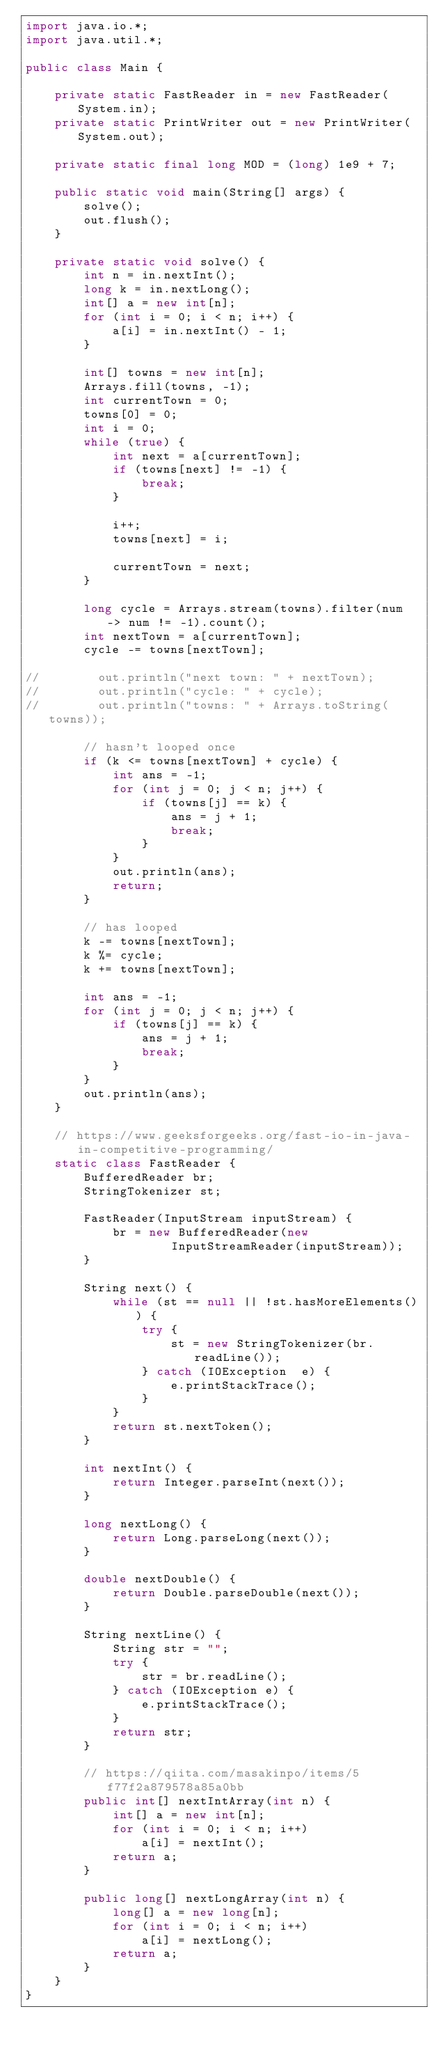Convert code to text. <code><loc_0><loc_0><loc_500><loc_500><_Java_>import java.io.*;
import java.util.*;

public class Main {

    private static FastReader in = new FastReader(System.in);
    private static PrintWriter out = new PrintWriter(System.out);

    private static final long MOD = (long) 1e9 + 7;

    public static void main(String[] args) {
        solve();
        out.flush();
    }

    private static void solve() {
        int n = in.nextInt();
        long k = in.nextLong();
        int[] a = new int[n];
        for (int i = 0; i < n; i++) {
            a[i] = in.nextInt() - 1;
        }

        int[] towns = new int[n];
        Arrays.fill(towns, -1);
        int currentTown = 0;
        towns[0] = 0;
        int i = 0;
        while (true) {
            int next = a[currentTown];
            if (towns[next] != -1) {
                break;
            }

            i++;
            towns[next] = i;

            currentTown = next;
        }

        long cycle = Arrays.stream(towns).filter(num -> num != -1).count();
        int nextTown = a[currentTown];
        cycle -= towns[nextTown];

//        out.println("next town: " + nextTown);
//        out.println("cycle: " + cycle);
//        out.println("towns: " + Arrays.toString(towns));

        // hasn't looped once
        if (k <= towns[nextTown] + cycle) {
            int ans = -1;
            for (int j = 0; j < n; j++) {
                if (towns[j] == k) {
                    ans = j + 1;
                    break;
                }
            }
            out.println(ans);
            return;
        }

        // has looped
        k -= towns[nextTown];
        k %= cycle;
        k += towns[nextTown];

        int ans = -1;
        for (int j = 0; j < n; j++) {
            if (towns[j] == k) {
                ans = j + 1;
                break;
            }
        }
        out.println(ans);
    }

    // https://www.geeksforgeeks.org/fast-io-in-java-in-competitive-programming/
    static class FastReader {
        BufferedReader br;
        StringTokenizer st;

        FastReader(InputStream inputStream) {
            br = new BufferedReader(new
                    InputStreamReader(inputStream));
        }

        String next() {
            while (st == null || !st.hasMoreElements()) {
                try {
                    st = new StringTokenizer(br.readLine());
                } catch (IOException  e) {
                    e.printStackTrace();
                }
            }
            return st.nextToken();
        }

        int nextInt() {
            return Integer.parseInt(next());
        }

        long nextLong() {
            return Long.parseLong(next());
        }

        double nextDouble() {
            return Double.parseDouble(next());
        }

        String nextLine() {
            String str = "";
            try {
                str = br.readLine();
            } catch (IOException e) {
                e.printStackTrace();
            }
            return str;
        }

        // https://qiita.com/masakinpo/items/5f77f2a879578a85a0bb
        public int[] nextIntArray(int n) {
            int[] a = new int[n];
            for (int i = 0; i < n; i++)
                a[i] = nextInt();
            return a;
        }

        public long[] nextLongArray(int n) {
            long[] a = new long[n];
            for (int i = 0; i < n; i++)
                a[i] = nextLong();
            return a;
        }
    }
}
</code> 